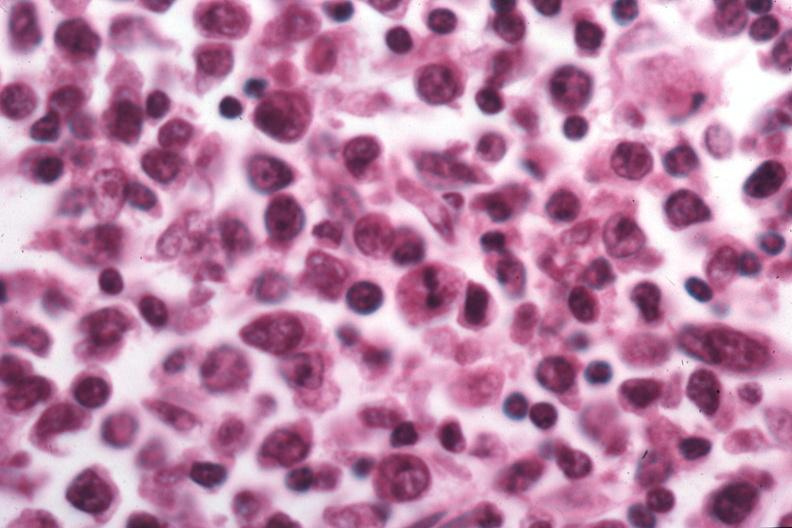s mucoepidermoid carcinoma present?
Answer the question using a single word or phrase. No 